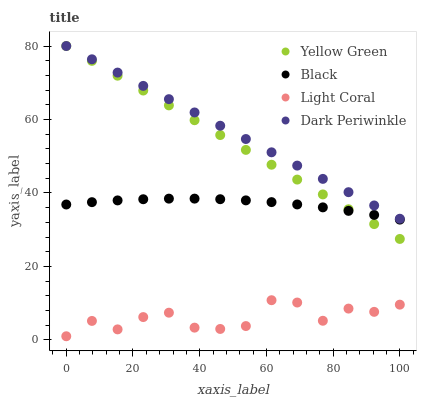Does Light Coral have the minimum area under the curve?
Answer yes or no. Yes. Does Dark Periwinkle have the maximum area under the curve?
Answer yes or no. Yes. Does Black have the minimum area under the curve?
Answer yes or no. No. Does Black have the maximum area under the curve?
Answer yes or no. No. Is Dark Periwinkle the smoothest?
Answer yes or no. Yes. Is Light Coral the roughest?
Answer yes or no. Yes. Is Black the smoothest?
Answer yes or no. No. Is Black the roughest?
Answer yes or no. No. Does Light Coral have the lowest value?
Answer yes or no. Yes. Does Black have the lowest value?
Answer yes or no. No. Does Dark Periwinkle have the highest value?
Answer yes or no. Yes. Does Black have the highest value?
Answer yes or no. No. Is Light Coral less than Black?
Answer yes or no. Yes. Is Yellow Green greater than Light Coral?
Answer yes or no. Yes. Does Black intersect Yellow Green?
Answer yes or no. Yes. Is Black less than Yellow Green?
Answer yes or no. No. Is Black greater than Yellow Green?
Answer yes or no. No. Does Light Coral intersect Black?
Answer yes or no. No. 